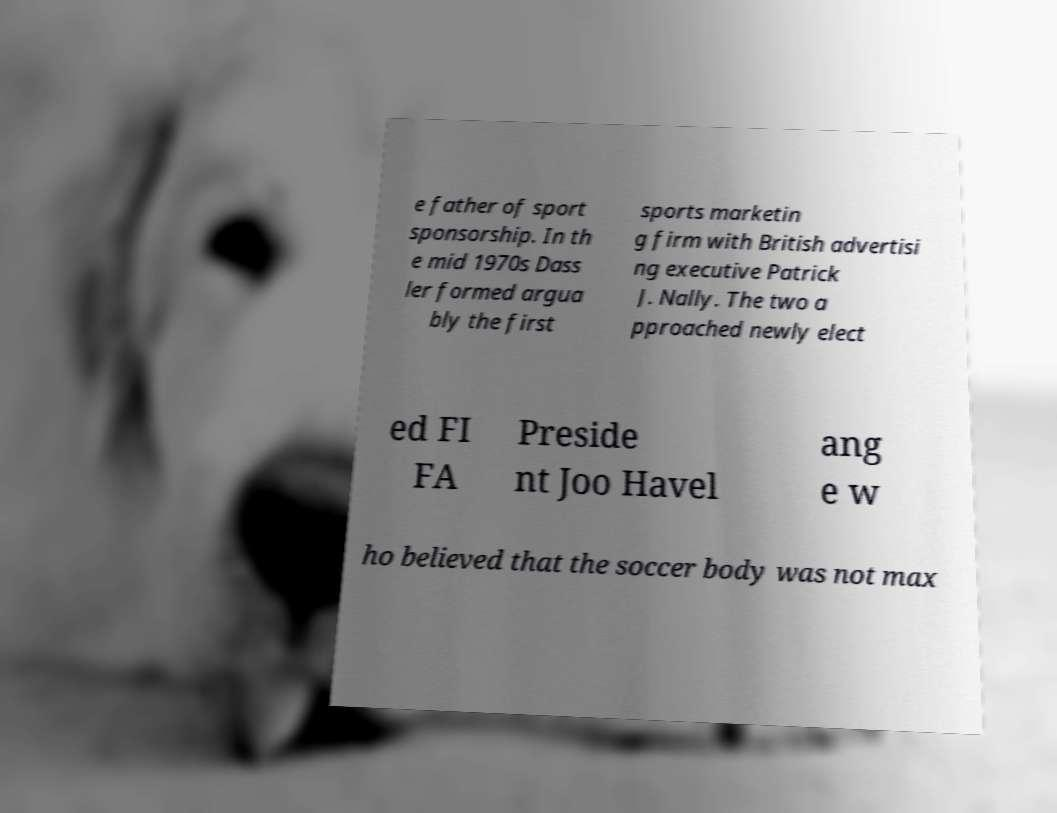Could you extract and type out the text from this image? e father of sport sponsorship. In th e mid 1970s Dass ler formed argua bly the first sports marketin g firm with British advertisi ng executive Patrick J. Nally. The two a pproached newly elect ed FI FA Preside nt Joo Havel ang e w ho believed that the soccer body was not max 